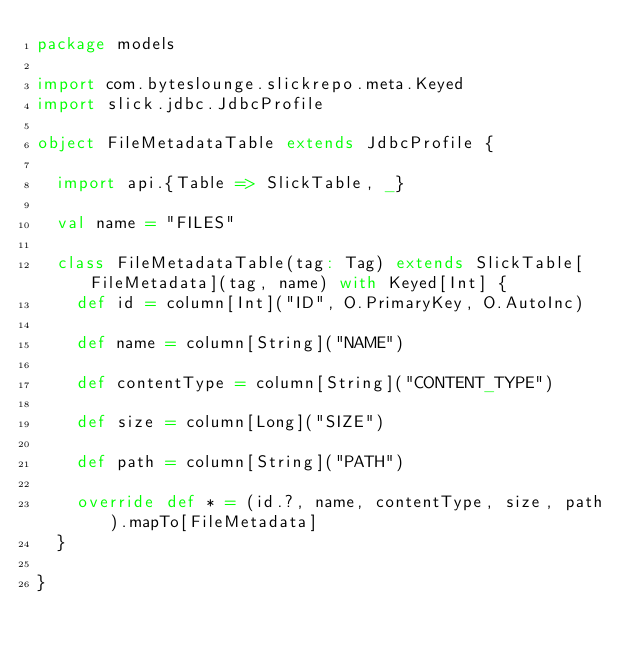<code> <loc_0><loc_0><loc_500><loc_500><_Scala_>package models

import com.byteslounge.slickrepo.meta.Keyed
import slick.jdbc.JdbcProfile

object FileMetadataTable extends JdbcProfile {

  import api.{Table => SlickTable, _}

  val name = "FILES"

  class FileMetadataTable(tag: Tag) extends SlickTable[FileMetadata](tag, name) with Keyed[Int] {
    def id = column[Int]("ID", O.PrimaryKey, O.AutoInc)

    def name = column[String]("NAME")

    def contentType = column[String]("CONTENT_TYPE")

    def size = column[Long]("SIZE")

    def path = column[String]("PATH")

    override def * = (id.?, name, contentType, size, path).mapTo[FileMetadata]
  }

}
</code> 